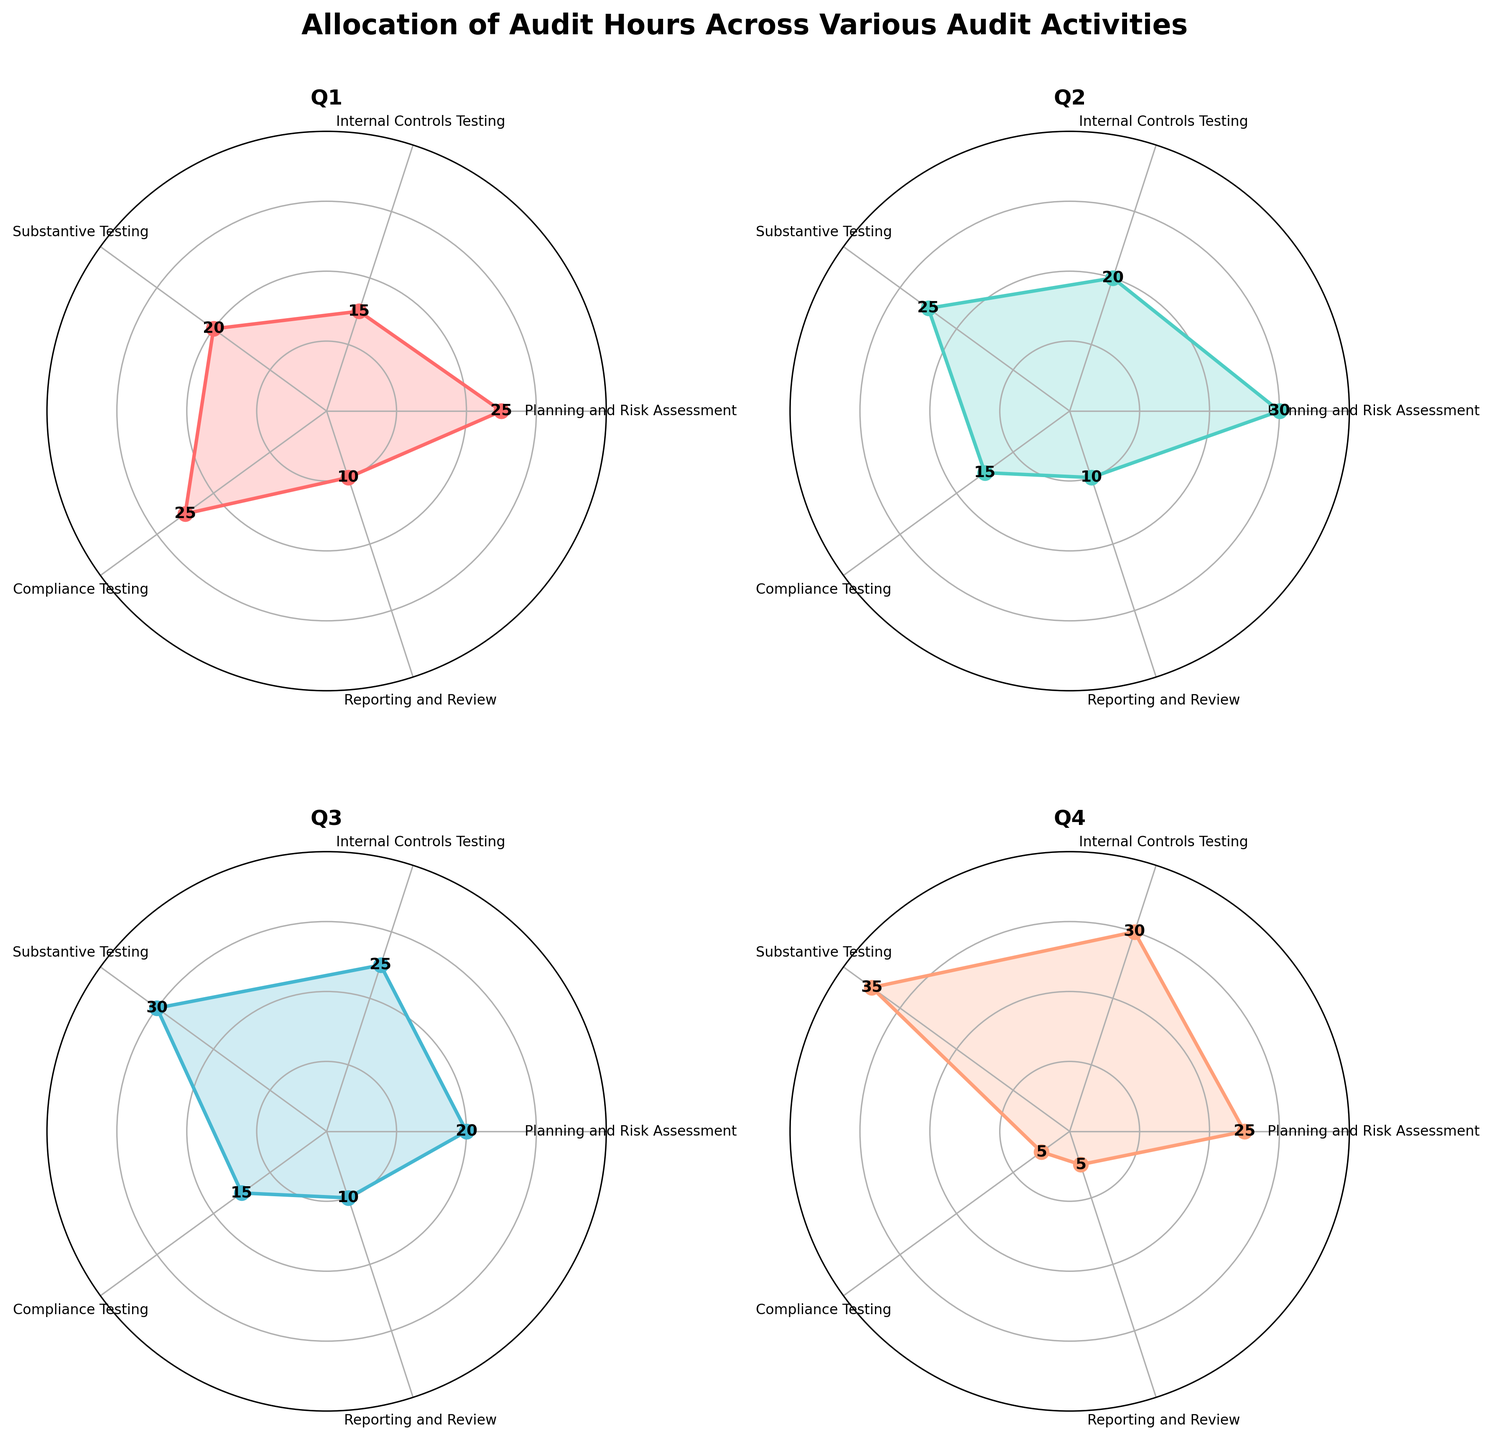What is the title of the figure? The title of the figure is provided at the top of the chart, which usually summarizes the main content or focus of the visual data presented.
Answer: Allocation of Audit Hours Across Various Audit Activities How many audit activities are shown in each subplot? The categories of audit activities are depicted as labels around the polar chart. Counting each one provides the total.
Answer: 5 Which quarter has the highest number of hours allocated to Substantive Testing? Looking at the Substantive Testing category in each subplot, compare the values across all quarters to identify the highest one.
Answer: Q4 What is the combined total of hours allocated to Compliance Testing over all the quarters? Add the values for Compliance Testing from Q1, Q2, Q3, and Q4: 25 + 15 + 15 + 5.
Answer: 60 Which quarter had the lowest number of hours allocated to Reporting and Review? Compare the values for Reporting and Review across all quarters to find the smallest one.
Answer: Q4 In which quarter did Planning and Risk Assessment receive exactly 25 hours? Look at the Planning and Risk Assessment category, identify the quarters that have a value of 25 hours, and list them.
Answer: Q1, Q4 How do the hours allocated to Internal Controls Testing change from Q1 to Q4? Observe the values for Internal Controls Testing in Q1 through Q4 and describe the changes. Q1: 15, Q2: 20, Q3: 25, Q4: 30.
Answer: They increase consistently If you average the hours for Substantive Testing across all quarters, what is the result? Sum the hours for Substantive Testing across all quarters: 20 + 25 + 30 + 35 = 110. Then, divide by the number of quarters (4). 110/4.
Answer: 27.5 Which audit activity shows the least variation in allocated hours across the quarters? Compare the range (maximum - minimum) of hours for each audit activity across the quarters. The smaller the range, the lesser the variation.
Answer: Reporting and Review How does the allocation of hours for Planning and Risk Assessment in Q2 compare to Q3? Identify the values for Planning and Risk Assessment in Q2 and Q3, then compare them. Q2: 30, Q3: 20.
Answer: Q2 is greater than Q3 